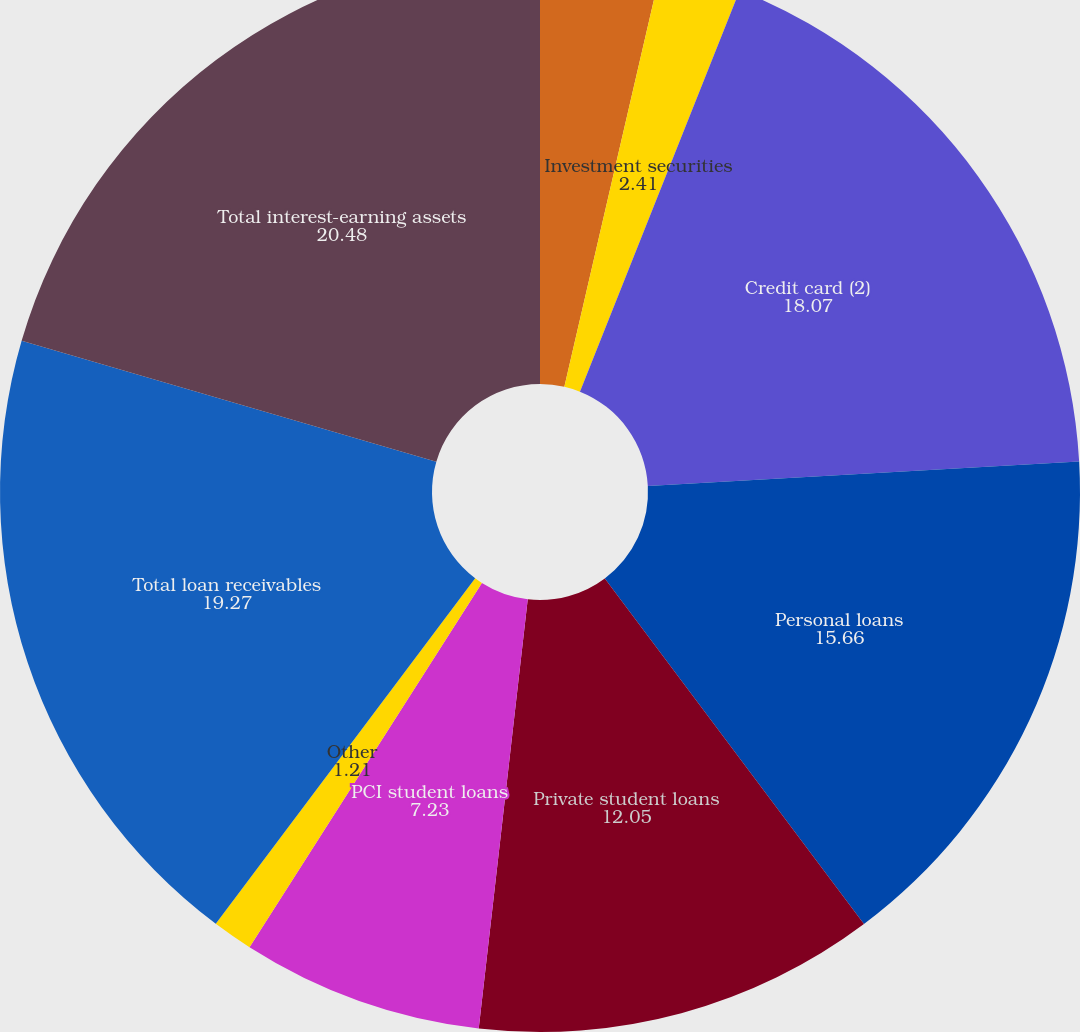Convert chart. <chart><loc_0><loc_0><loc_500><loc_500><pie_chart><fcel>Cash and cash equivalents<fcel>Restricted cash<fcel>Investment securities<fcel>Credit card (2)<fcel>Personal loans<fcel>Private student loans<fcel>PCI student loans<fcel>Other<fcel>Total loan receivables<fcel>Total interest-earning assets<nl><fcel>3.62%<fcel>0.0%<fcel>2.41%<fcel>18.07%<fcel>15.66%<fcel>12.05%<fcel>7.23%<fcel>1.21%<fcel>19.27%<fcel>20.48%<nl></chart> 